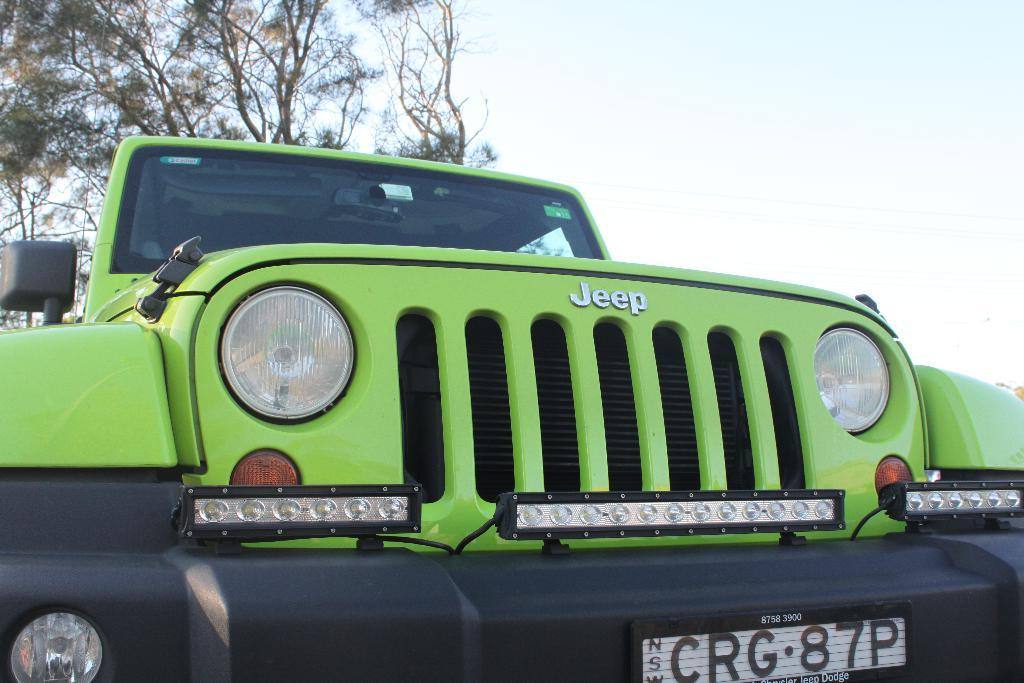What type of vehicle is in the image? There is a jeep in the image. What color is the jeep? The jeep is green. What feature can be seen at the bottom of the jeep? There is a black bumper at the bottom of the jeep. What is located on the left side of the image? There is a tree on the left side of the image. What is visible at the top of the image? The sky is visible at the top of the image. What scent is emanating from the jeep in the image? There is no information about a scent in the image, as it only shows a green jeep with a black bumper and a tree on the left side. 